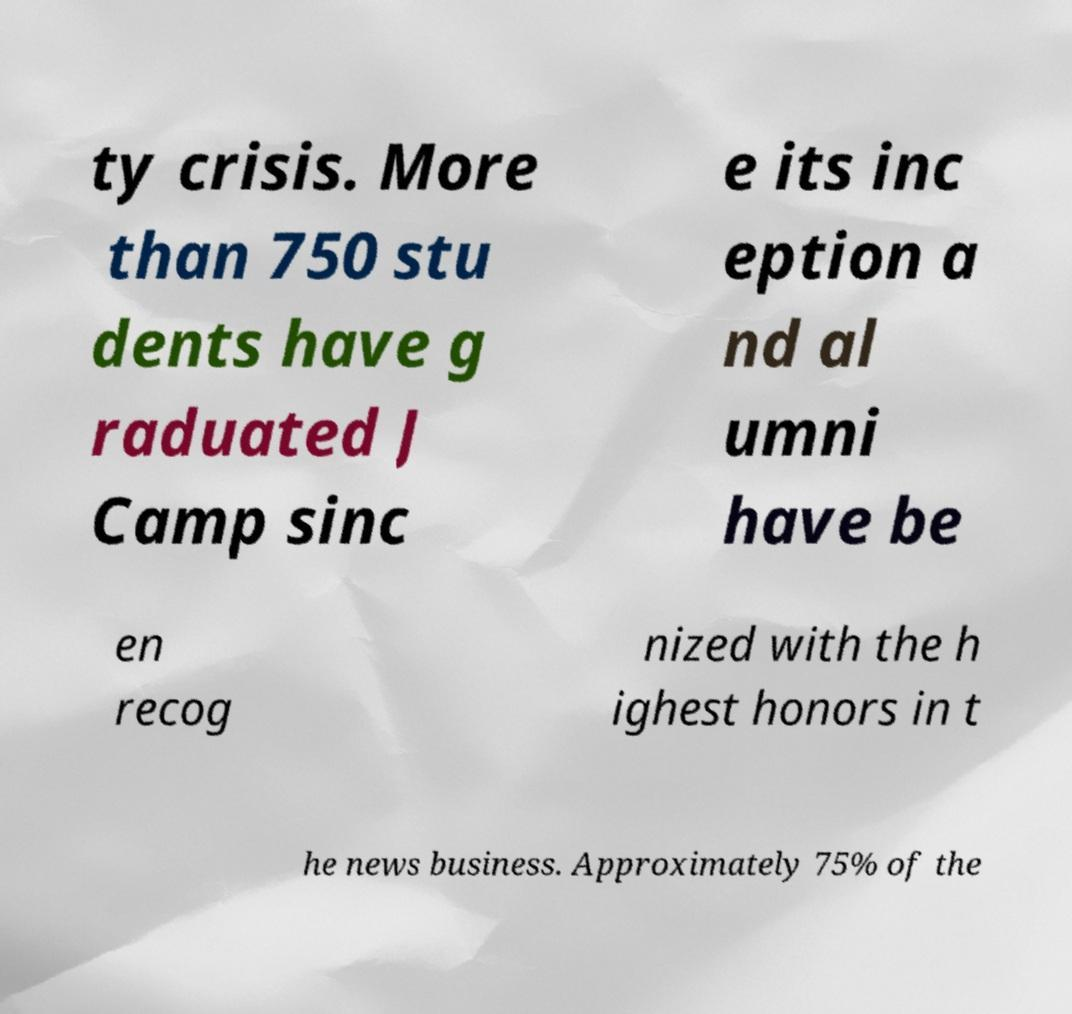There's text embedded in this image that I need extracted. Can you transcribe it verbatim? ty crisis. More than 750 stu dents have g raduated J Camp sinc e its inc eption a nd al umni have be en recog nized with the h ighest honors in t he news business. Approximately 75% of the 